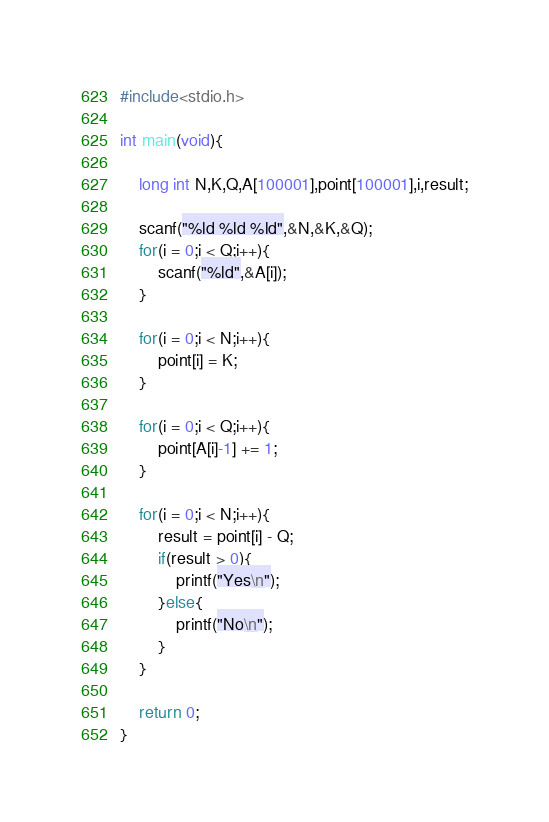<code> <loc_0><loc_0><loc_500><loc_500><_C_>#include<stdio.h>

int main(void){

    long int N,K,Q,A[100001],point[100001],i,result;

    scanf("%ld %ld %ld",&N,&K,&Q);
    for(i = 0;i < Q;i++){
        scanf("%ld",&A[i]);
    }

    for(i = 0;i < N;i++){
        point[i] = K;
    }

    for(i = 0;i < Q;i++){
        point[A[i]-1] += 1;
    }

    for(i = 0;i < N;i++){
        result = point[i] - Q;
        if(result > 0){
            printf("Yes\n");
        }else{
            printf("No\n");
        }
    }

    return 0;
}</code> 